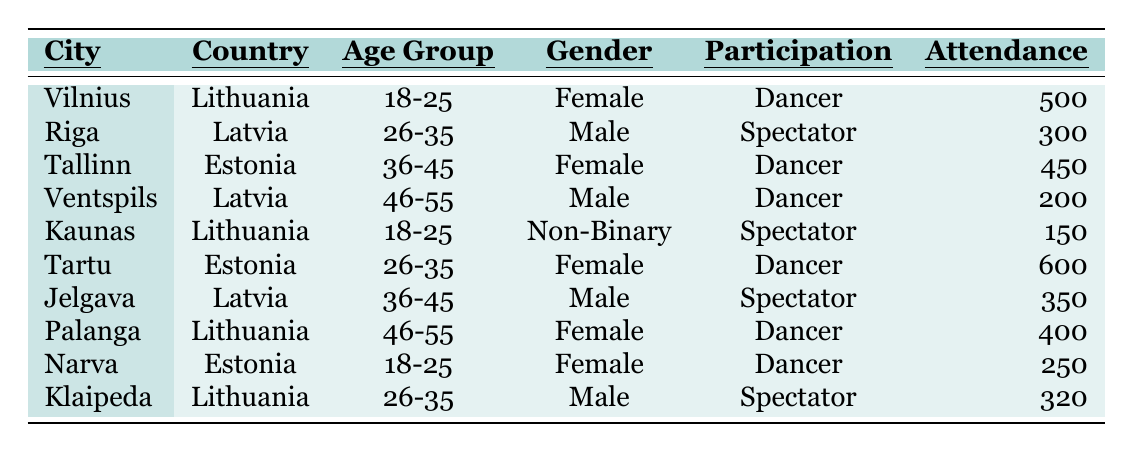How many attendees are dancers from Tartu? According to the table, Tartu has 600 attendees who are classified as dancers.
Answer: 600 What is the total attendance of female dancers across all cities? The female dancers are from Vilnius (500), Tallinn (450), Tartu (600), and Palanga (400). Summing those values gives 500 + 450 + 600 + 400 = 1950.
Answer: 1950 Is there any non-binary attendee from Riga? The table does not list any non-binary attendees from Riga; it only shows male and female attendees.
Answer: No Which city has the highest number of male spectators? In the table, Klaipeda has 320 male spectators, while Jelgava has 350 male spectators. The highest is therefore in Jelgava.
Answer: Jelgava How many more dancers attended the festival in Tartu than in Ventspils? Tartu had 600 dancers and Ventspils had 200 dancers. The difference is 600 - 200 = 400.
Answer: 400 What percentage of the total attendees were over 35 years old? The total attendance is 500 + 300 + 450 + 200 + 150 + 600 + 350 + 400 + 250 + 320 = 3020. The groups over 35 years old are Ventspils (200), Jelgava (350), Tallinn (450), and Palanga (400). Their total is 200 + 350 + 450 + 400 = 1400, so the percentage is (1400 / 3020) * 100 ≈ 46.35%.
Answer: 46.35% Which city had the highest attendance of spectators? The table shows Klaipeda (320) and Riga (300). Klaipeda has the highest number of spectators at 320.
Answer: Klaipeda Are there more female attendees or male attendees overall? Total male attendees: Riga (300), Ventspils (200), Jelgava (350), Klaipeda (320) = 1170. Total female attendees: Vilnius (500), Tallinn (450), Tartu (600), Palanga (400), Narva (250) = 2200. Female attendees are more numerous than male.
Answer: Female attendees are more 